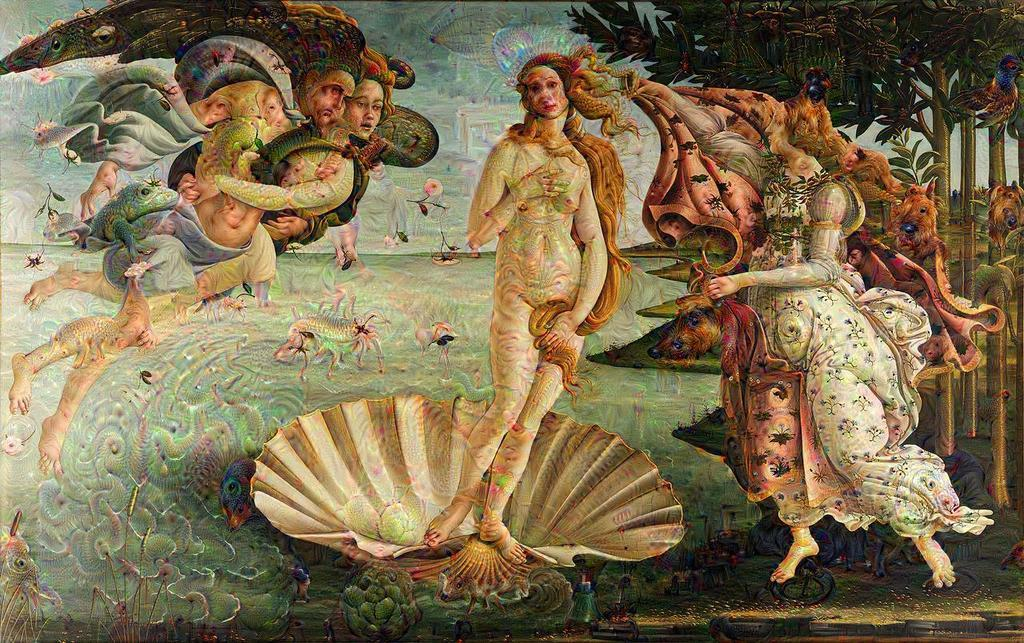What is the main subject of the image? The image contains a painting. What is being depicted in the painting? The painting depicts people and trees. Are there any other elements in the painting besides people and trees? Yes, the painting contains other things. What type of string is being used to hold up the trees in the painting? There is no string present in the painting; the trees are depicted as standing on their own. 